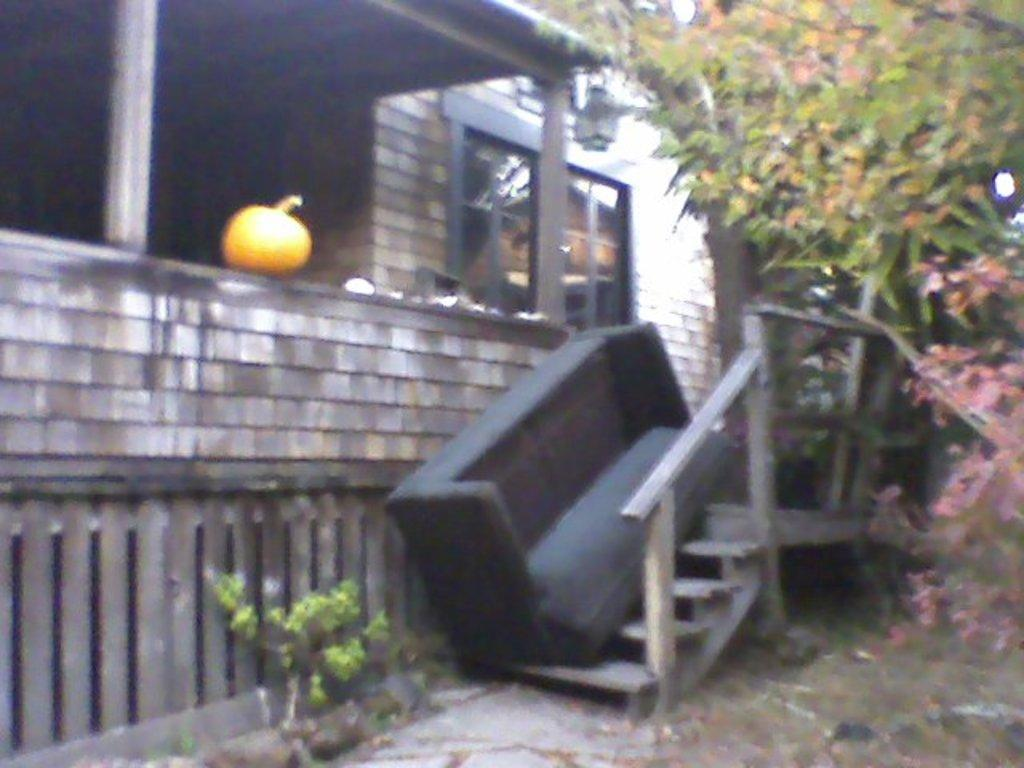What type of house is shown in the image? There is a wooden house in the image. Are there any specific features of the house? Yes, the house has stairs. What is an unusual object placed on the stairs? A sofa is present on the stairs. What decorative item can be seen on the wall? There is a pumpkin on the wall. What type of vegetation is visible in the image? Trees are visible in the top right corner of the image. What type of breakfast is being served on the sofa in the image? There is no breakfast or any food visible in the image; it only shows a sofa on the stairs. What type of pin is holding the pumpkin to the wall in the image? There is no pin mentioned or visible in the image; the pumpkin is simply on the wall. 